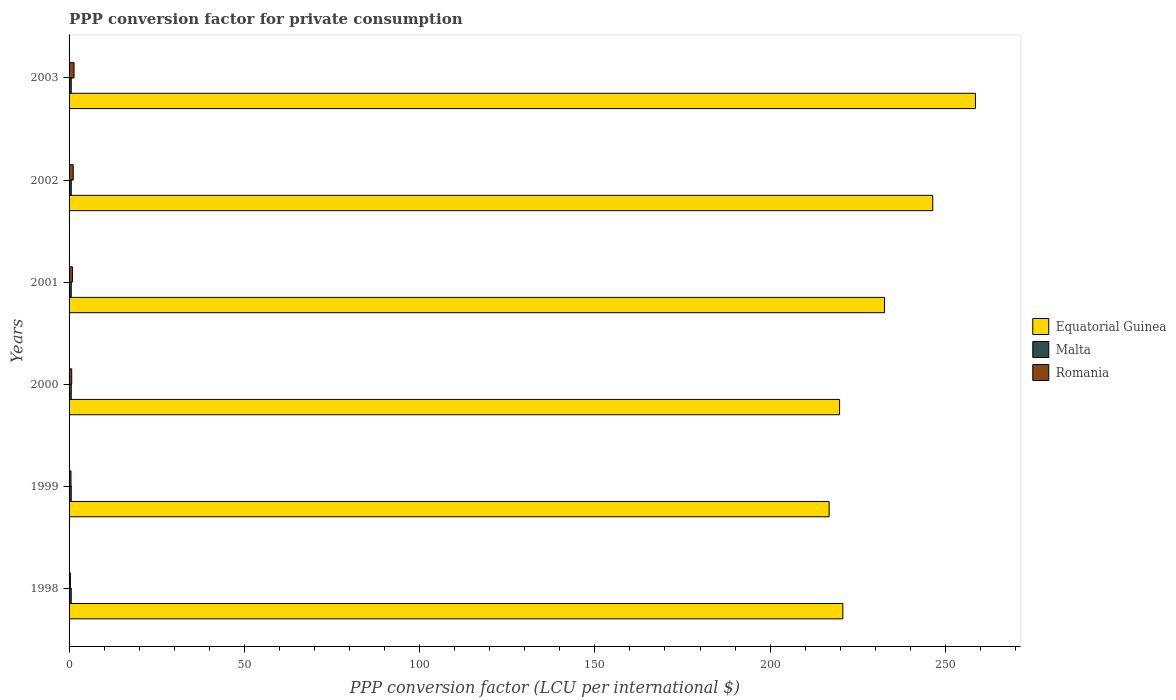How many different coloured bars are there?
Your response must be concise. 3. How many groups of bars are there?
Your answer should be very brief. 6. Are the number of bars per tick equal to the number of legend labels?
Provide a short and direct response. Yes. In how many cases, is the number of bars for a given year not equal to the number of legend labels?
Provide a succinct answer. 0. What is the PPP conversion factor for private consumption in Equatorial Guinea in 2000?
Give a very brief answer. 219.83. Across all years, what is the maximum PPP conversion factor for private consumption in Equatorial Guinea?
Provide a succinct answer. 258.58. Across all years, what is the minimum PPP conversion factor for private consumption in Malta?
Your response must be concise. 0.62. In which year was the PPP conversion factor for private consumption in Romania maximum?
Your response must be concise. 2003. What is the total PPP conversion factor for private consumption in Romania in the graph?
Provide a succinct answer. 5.26. What is the difference between the PPP conversion factor for private consumption in Romania in 2000 and that in 2001?
Offer a terse response. -0.2. What is the difference between the PPP conversion factor for private consumption in Equatorial Guinea in 1999 and the PPP conversion factor for private consumption in Malta in 2003?
Your answer should be compact. 216.21. What is the average PPP conversion factor for private consumption in Equatorial Guinea per year?
Offer a very short reply. 232.51. In the year 2003, what is the difference between the PPP conversion factor for private consumption in Equatorial Guinea and PPP conversion factor for private consumption in Malta?
Provide a short and direct response. 257.96. In how many years, is the PPP conversion factor for private consumption in Romania greater than 40 LCU?
Keep it short and to the point. 0. What is the ratio of the PPP conversion factor for private consumption in Malta in 1999 to that in 2001?
Make the answer very short. 1. Is the PPP conversion factor for private consumption in Romania in 2000 less than that in 2001?
Give a very brief answer. Yes. What is the difference between the highest and the second highest PPP conversion factor for private consumption in Romania?
Your answer should be very brief. 0.23. What is the difference between the highest and the lowest PPP conversion factor for private consumption in Malta?
Keep it short and to the point. 0.01. What does the 3rd bar from the top in 2001 represents?
Provide a succinct answer. Equatorial Guinea. What does the 2nd bar from the bottom in 2001 represents?
Offer a very short reply. Malta. Is it the case that in every year, the sum of the PPP conversion factor for private consumption in Malta and PPP conversion factor for private consumption in Romania is greater than the PPP conversion factor for private consumption in Equatorial Guinea?
Make the answer very short. No. Are all the bars in the graph horizontal?
Make the answer very short. Yes. What is the difference between two consecutive major ticks on the X-axis?
Ensure brevity in your answer.  50. Does the graph contain any zero values?
Provide a short and direct response. No. Does the graph contain grids?
Your response must be concise. No. How are the legend labels stacked?
Your answer should be very brief. Vertical. What is the title of the graph?
Provide a succinct answer. PPP conversion factor for private consumption. What is the label or title of the X-axis?
Your answer should be very brief. PPP conversion factor (LCU per international $). What is the label or title of the Y-axis?
Give a very brief answer. Years. What is the PPP conversion factor (LCU per international $) in Equatorial Guinea in 1998?
Your answer should be very brief. 220.76. What is the PPP conversion factor (LCU per international $) in Malta in 1998?
Your response must be concise. 0.62. What is the PPP conversion factor (LCU per international $) in Romania in 1998?
Provide a short and direct response. 0.38. What is the PPP conversion factor (LCU per international $) in Equatorial Guinea in 1999?
Offer a very short reply. 216.84. What is the PPP conversion factor (LCU per international $) in Malta in 1999?
Your answer should be compact. 0.62. What is the PPP conversion factor (LCU per international $) in Romania in 1999?
Offer a terse response. 0.55. What is the PPP conversion factor (LCU per international $) of Equatorial Guinea in 2000?
Make the answer very short. 219.83. What is the PPP conversion factor (LCU per international $) in Malta in 2000?
Provide a succinct answer. 0.62. What is the PPP conversion factor (LCU per international $) in Romania in 2000?
Your response must be concise. 0.76. What is the PPP conversion factor (LCU per international $) in Equatorial Guinea in 2001?
Offer a very short reply. 232.65. What is the PPP conversion factor (LCU per international $) in Malta in 2001?
Offer a very short reply. 0.62. What is the PPP conversion factor (LCU per international $) in Romania in 2001?
Provide a succinct answer. 0.96. What is the PPP conversion factor (LCU per international $) of Equatorial Guinea in 2002?
Your answer should be compact. 246.41. What is the PPP conversion factor (LCU per international $) of Malta in 2002?
Make the answer very short. 0.63. What is the PPP conversion factor (LCU per international $) in Romania in 2002?
Your answer should be very brief. 1.19. What is the PPP conversion factor (LCU per international $) in Equatorial Guinea in 2003?
Make the answer very short. 258.58. What is the PPP conversion factor (LCU per international $) in Malta in 2003?
Offer a terse response. 0.62. What is the PPP conversion factor (LCU per international $) in Romania in 2003?
Offer a very short reply. 1.42. Across all years, what is the maximum PPP conversion factor (LCU per international $) of Equatorial Guinea?
Offer a very short reply. 258.58. Across all years, what is the maximum PPP conversion factor (LCU per international $) in Malta?
Keep it short and to the point. 0.63. Across all years, what is the maximum PPP conversion factor (LCU per international $) in Romania?
Give a very brief answer. 1.42. Across all years, what is the minimum PPP conversion factor (LCU per international $) in Equatorial Guinea?
Provide a succinct answer. 216.84. Across all years, what is the minimum PPP conversion factor (LCU per international $) in Malta?
Offer a terse response. 0.62. Across all years, what is the minimum PPP conversion factor (LCU per international $) of Romania?
Ensure brevity in your answer.  0.38. What is the total PPP conversion factor (LCU per international $) in Equatorial Guinea in the graph?
Offer a very short reply. 1395.06. What is the total PPP conversion factor (LCU per international $) of Malta in the graph?
Your answer should be compact. 3.73. What is the total PPP conversion factor (LCU per international $) in Romania in the graph?
Your response must be concise. 5.26. What is the difference between the PPP conversion factor (LCU per international $) of Equatorial Guinea in 1998 and that in 1999?
Offer a very short reply. 3.92. What is the difference between the PPP conversion factor (LCU per international $) of Malta in 1998 and that in 1999?
Your answer should be very brief. 0. What is the difference between the PPP conversion factor (LCU per international $) of Romania in 1998 and that in 1999?
Ensure brevity in your answer.  -0.17. What is the difference between the PPP conversion factor (LCU per international $) of Equatorial Guinea in 1998 and that in 2000?
Your answer should be compact. 0.93. What is the difference between the PPP conversion factor (LCU per international $) in Malta in 1998 and that in 2000?
Give a very brief answer. 0.01. What is the difference between the PPP conversion factor (LCU per international $) of Romania in 1998 and that in 2000?
Give a very brief answer. -0.38. What is the difference between the PPP conversion factor (LCU per international $) of Equatorial Guinea in 1998 and that in 2001?
Your response must be concise. -11.89. What is the difference between the PPP conversion factor (LCU per international $) in Malta in 1998 and that in 2001?
Your answer should be compact. 0. What is the difference between the PPP conversion factor (LCU per international $) in Romania in 1998 and that in 2001?
Provide a succinct answer. -0.58. What is the difference between the PPP conversion factor (LCU per international $) in Equatorial Guinea in 1998 and that in 2002?
Offer a very short reply. -25.65. What is the difference between the PPP conversion factor (LCU per international $) of Malta in 1998 and that in 2002?
Provide a short and direct response. -0. What is the difference between the PPP conversion factor (LCU per international $) in Romania in 1998 and that in 2002?
Your answer should be very brief. -0.81. What is the difference between the PPP conversion factor (LCU per international $) in Equatorial Guinea in 1998 and that in 2003?
Provide a short and direct response. -37.82. What is the difference between the PPP conversion factor (LCU per international $) in Malta in 1998 and that in 2003?
Make the answer very short. 0. What is the difference between the PPP conversion factor (LCU per international $) of Romania in 1998 and that in 2003?
Provide a succinct answer. -1.04. What is the difference between the PPP conversion factor (LCU per international $) of Equatorial Guinea in 1999 and that in 2000?
Your answer should be compact. -2.99. What is the difference between the PPP conversion factor (LCU per international $) of Malta in 1999 and that in 2000?
Give a very brief answer. 0. What is the difference between the PPP conversion factor (LCU per international $) of Romania in 1999 and that in 2000?
Your response must be concise. -0.21. What is the difference between the PPP conversion factor (LCU per international $) of Equatorial Guinea in 1999 and that in 2001?
Your response must be concise. -15.82. What is the difference between the PPP conversion factor (LCU per international $) of Romania in 1999 and that in 2001?
Keep it short and to the point. -0.41. What is the difference between the PPP conversion factor (LCU per international $) in Equatorial Guinea in 1999 and that in 2002?
Offer a terse response. -29.57. What is the difference between the PPP conversion factor (LCU per international $) in Malta in 1999 and that in 2002?
Give a very brief answer. -0.01. What is the difference between the PPP conversion factor (LCU per international $) in Romania in 1999 and that in 2002?
Provide a short and direct response. -0.64. What is the difference between the PPP conversion factor (LCU per international $) of Equatorial Guinea in 1999 and that in 2003?
Keep it short and to the point. -41.75. What is the difference between the PPP conversion factor (LCU per international $) of Malta in 1999 and that in 2003?
Make the answer very short. -0. What is the difference between the PPP conversion factor (LCU per international $) of Romania in 1999 and that in 2003?
Keep it short and to the point. -0.87. What is the difference between the PPP conversion factor (LCU per international $) in Equatorial Guinea in 2000 and that in 2001?
Make the answer very short. -12.83. What is the difference between the PPP conversion factor (LCU per international $) in Malta in 2000 and that in 2001?
Provide a succinct answer. -0. What is the difference between the PPP conversion factor (LCU per international $) in Romania in 2000 and that in 2001?
Ensure brevity in your answer.  -0.2. What is the difference between the PPP conversion factor (LCU per international $) in Equatorial Guinea in 2000 and that in 2002?
Keep it short and to the point. -26.58. What is the difference between the PPP conversion factor (LCU per international $) in Malta in 2000 and that in 2002?
Your answer should be compact. -0.01. What is the difference between the PPP conversion factor (LCU per international $) in Romania in 2000 and that in 2002?
Your response must be concise. -0.43. What is the difference between the PPP conversion factor (LCU per international $) in Equatorial Guinea in 2000 and that in 2003?
Provide a short and direct response. -38.76. What is the difference between the PPP conversion factor (LCU per international $) of Malta in 2000 and that in 2003?
Your response must be concise. -0.01. What is the difference between the PPP conversion factor (LCU per international $) in Romania in 2000 and that in 2003?
Provide a short and direct response. -0.66. What is the difference between the PPP conversion factor (LCU per international $) of Equatorial Guinea in 2001 and that in 2002?
Provide a succinct answer. -13.76. What is the difference between the PPP conversion factor (LCU per international $) in Malta in 2001 and that in 2002?
Your answer should be compact. -0.01. What is the difference between the PPP conversion factor (LCU per international $) in Romania in 2001 and that in 2002?
Offer a terse response. -0.23. What is the difference between the PPP conversion factor (LCU per international $) in Equatorial Guinea in 2001 and that in 2003?
Your response must be concise. -25.93. What is the difference between the PPP conversion factor (LCU per international $) in Malta in 2001 and that in 2003?
Offer a very short reply. -0. What is the difference between the PPP conversion factor (LCU per international $) in Romania in 2001 and that in 2003?
Offer a terse response. -0.46. What is the difference between the PPP conversion factor (LCU per international $) of Equatorial Guinea in 2002 and that in 2003?
Provide a succinct answer. -12.18. What is the difference between the PPP conversion factor (LCU per international $) in Malta in 2002 and that in 2003?
Your answer should be very brief. 0.01. What is the difference between the PPP conversion factor (LCU per international $) of Romania in 2002 and that in 2003?
Ensure brevity in your answer.  -0.23. What is the difference between the PPP conversion factor (LCU per international $) of Equatorial Guinea in 1998 and the PPP conversion factor (LCU per international $) of Malta in 1999?
Your response must be concise. 220.14. What is the difference between the PPP conversion factor (LCU per international $) of Equatorial Guinea in 1998 and the PPP conversion factor (LCU per international $) of Romania in 1999?
Your response must be concise. 220.21. What is the difference between the PPP conversion factor (LCU per international $) in Malta in 1998 and the PPP conversion factor (LCU per international $) in Romania in 1999?
Offer a terse response. 0.07. What is the difference between the PPP conversion factor (LCU per international $) of Equatorial Guinea in 1998 and the PPP conversion factor (LCU per international $) of Malta in 2000?
Your response must be concise. 220.14. What is the difference between the PPP conversion factor (LCU per international $) in Equatorial Guinea in 1998 and the PPP conversion factor (LCU per international $) in Romania in 2000?
Ensure brevity in your answer.  220. What is the difference between the PPP conversion factor (LCU per international $) of Malta in 1998 and the PPP conversion factor (LCU per international $) of Romania in 2000?
Your answer should be compact. -0.13. What is the difference between the PPP conversion factor (LCU per international $) in Equatorial Guinea in 1998 and the PPP conversion factor (LCU per international $) in Malta in 2001?
Keep it short and to the point. 220.14. What is the difference between the PPP conversion factor (LCU per international $) of Equatorial Guinea in 1998 and the PPP conversion factor (LCU per international $) of Romania in 2001?
Your response must be concise. 219.8. What is the difference between the PPP conversion factor (LCU per international $) of Malta in 1998 and the PPP conversion factor (LCU per international $) of Romania in 2001?
Give a very brief answer. -0.34. What is the difference between the PPP conversion factor (LCU per international $) in Equatorial Guinea in 1998 and the PPP conversion factor (LCU per international $) in Malta in 2002?
Make the answer very short. 220.13. What is the difference between the PPP conversion factor (LCU per international $) in Equatorial Guinea in 1998 and the PPP conversion factor (LCU per international $) in Romania in 2002?
Your response must be concise. 219.57. What is the difference between the PPP conversion factor (LCU per international $) of Malta in 1998 and the PPP conversion factor (LCU per international $) of Romania in 2002?
Your response must be concise. -0.56. What is the difference between the PPP conversion factor (LCU per international $) of Equatorial Guinea in 1998 and the PPP conversion factor (LCU per international $) of Malta in 2003?
Provide a succinct answer. 220.14. What is the difference between the PPP conversion factor (LCU per international $) of Equatorial Guinea in 1998 and the PPP conversion factor (LCU per international $) of Romania in 2003?
Give a very brief answer. 219.34. What is the difference between the PPP conversion factor (LCU per international $) in Malta in 1998 and the PPP conversion factor (LCU per international $) in Romania in 2003?
Your answer should be very brief. -0.8. What is the difference between the PPP conversion factor (LCU per international $) in Equatorial Guinea in 1999 and the PPP conversion factor (LCU per international $) in Malta in 2000?
Ensure brevity in your answer.  216.22. What is the difference between the PPP conversion factor (LCU per international $) of Equatorial Guinea in 1999 and the PPP conversion factor (LCU per international $) of Romania in 2000?
Your response must be concise. 216.08. What is the difference between the PPP conversion factor (LCU per international $) in Malta in 1999 and the PPP conversion factor (LCU per international $) in Romania in 2000?
Your answer should be very brief. -0.14. What is the difference between the PPP conversion factor (LCU per international $) in Equatorial Guinea in 1999 and the PPP conversion factor (LCU per international $) in Malta in 2001?
Make the answer very short. 216.21. What is the difference between the PPP conversion factor (LCU per international $) of Equatorial Guinea in 1999 and the PPP conversion factor (LCU per international $) of Romania in 2001?
Ensure brevity in your answer.  215.87. What is the difference between the PPP conversion factor (LCU per international $) of Malta in 1999 and the PPP conversion factor (LCU per international $) of Romania in 2001?
Your answer should be very brief. -0.34. What is the difference between the PPP conversion factor (LCU per international $) in Equatorial Guinea in 1999 and the PPP conversion factor (LCU per international $) in Malta in 2002?
Your answer should be very brief. 216.21. What is the difference between the PPP conversion factor (LCU per international $) in Equatorial Guinea in 1999 and the PPP conversion factor (LCU per international $) in Romania in 2002?
Your answer should be very brief. 215.65. What is the difference between the PPP conversion factor (LCU per international $) in Malta in 1999 and the PPP conversion factor (LCU per international $) in Romania in 2002?
Offer a terse response. -0.56. What is the difference between the PPP conversion factor (LCU per international $) in Equatorial Guinea in 1999 and the PPP conversion factor (LCU per international $) in Malta in 2003?
Keep it short and to the point. 216.21. What is the difference between the PPP conversion factor (LCU per international $) in Equatorial Guinea in 1999 and the PPP conversion factor (LCU per international $) in Romania in 2003?
Your answer should be compact. 215.42. What is the difference between the PPP conversion factor (LCU per international $) of Malta in 1999 and the PPP conversion factor (LCU per international $) of Romania in 2003?
Offer a terse response. -0.8. What is the difference between the PPP conversion factor (LCU per international $) in Equatorial Guinea in 2000 and the PPP conversion factor (LCU per international $) in Malta in 2001?
Offer a terse response. 219.2. What is the difference between the PPP conversion factor (LCU per international $) of Equatorial Guinea in 2000 and the PPP conversion factor (LCU per international $) of Romania in 2001?
Your answer should be very brief. 218.86. What is the difference between the PPP conversion factor (LCU per international $) of Malta in 2000 and the PPP conversion factor (LCU per international $) of Romania in 2001?
Offer a very short reply. -0.34. What is the difference between the PPP conversion factor (LCU per international $) of Equatorial Guinea in 2000 and the PPP conversion factor (LCU per international $) of Malta in 2002?
Your answer should be very brief. 219.2. What is the difference between the PPP conversion factor (LCU per international $) in Equatorial Guinea in 2000 and the PPP conversion factor (LCU per international $) in Romania in 2002?
Provide a succinct answer. 218.64. What is the difference between the PPP conversion factor (LCU per international $) of Malta in 2000 and the PPP conversion factor (LCU per international $) of Romania in 2002?
Give a very brief answer. -0.57. What is the difference between the PPP conversion factor (LCU per international $) in Equatorial Guinea in 2000 and the PPP conversion factor (LCU per international $) in Malta in 2003?
Provide a short and direct response. 219.2. What is the difference between the PPP conversion factor (LCU per international $) of Equatorial Guinea in 2000 and the PPP conversion factor (LCU per international $) of Romania in 2003?
Your response must be concise. 218.41. What is the difference between the PPP conversion factor (LCU per international $) of Malta in 2000 and the PPP conversion factor (LCU per international $) of Romania in 2003?
Your answer should be very brief. -0.8. What is the difference between the PPP conversion factor (LCU per international $) of Equatorial Guinea in 2001 and the PPP conversion factor (LCU per international $) of Malta in 2002?
Offer a terse response. 232.02. What is the difference between the PPP conversion factor (LCU per international $) in Equatorial Guinea in 2001 and the PPP conversion factor (LCU per international $) in Romania in 2002?
Keep it short and to the point. 231.46. What is the difference between the PPP conversion factor (LCU per international $) in Malta in 2001 and the PPP conversion factor (LCU per international $) in Romania in 2002?
Ensure brevity in your answer.  -0.57. What is the difference between the PPP conversion factor (LCU per international $) in Equatorial Guinea in 2001 and the PPP conversion factor (LCU per international $) in Malta in 2003?
Make the answer very short. 232.03. What is the difference between the PPP conversion factor (LCU per international $) of Equatorial Guinea in 2001 and the PPP conversion factor (LCU per international $) of Romania in 2003?
Provide a short and direct response. 231.23. What is the difference between the PPP conversion factor (LCU per international $) of Malta in 2001 and the PPP conversion factor (LCU per international $) of Romania in 2003?
Provide a short and direct response. -0.8. What is the difference between the PPP conversion factor (LCU per international $) of Equatorial Guinea in 2002 and the PPP conversion factor (LCU per international $) of Malta in 2003?
Give a very brief answer. 245.78. What is the difference between the PPP conversion factor (LCU per international $) of Equatorial Guinea in 2002 and the PPP conversion factor (LCU per international $) of Romania in 2003?
Your answer should be very brief. 244.99. What is the difference between the PPP conversion factor (LCU per international $) of Malta in 2002 and the PPP conversion factor (LCU per international $) of Romania in 2003?
Keep it short and to the point. -0.79. What is the average PPP conversion factor (LCU per international $) of Equatorial Guinea per year?
Give a very brief answer. 232.51. What is the average PPP conversion factor (LCU per international $) in Malta per year?
Your answer should be compact. 0.62. What is the average PPP conversion factor (LCU per international $) of Romania per year?
Your answer should be very brief. 0.88. In the year 1998, what is the difference between the PPP conversion factor (LCU per international $) of Equatorial Guinea and PPP conversion factor (LCU per international $) of Malta?
Give a very brief answer. 220.14. In the year 1998, what is the difference between the PPP conversion factor (LCU per international $) in Equatorial Guinea and PPP conversion factor (LCU per international $) in Romania?
Your answer should be compact. 220.38. In the year 1998, what is the difference between the PPP conversion factor (LCU per international $) in Malta and PPP conversion factor (LCU per international $) in Romania?
Give a very brief answer. 0.24. In the year 1999, what is the difference between the PPP conversion factor (LCU per international $) in Equatorial Guinea and PPP conversion factor (LCU per international $) in Malta?
Your answer should be very brief. 216.21. In the year 1999, what is the difference between the PPP conversion factor (LCU per international $) of Equatorial Guinea and PPP conversion factor (LCU per international $) of Romania?
Give a very brief answer. 216.28. In the year 1999, what is the difference between the PPP conversion factor (LCU per international $) of Malta and PPP conversion factor (LCU per international $) of Romania?
Provide a succinct answer. 0.07. In the year 2000, what is the difference between the PPP conversion factor (LCU per international $) of Equatorial Guinea and PPP conversion factor (LCU per international $) of Malta?
Offer a very short reply. 219.21. In the year 2000, what is the difference between the PPP conversion factor (LCU per international $) in Equatorial Guinea and PPP conversion factor (LCU per international $) in Romania?
Your answer should be very brief. 219.07. In the year 2000, what is the difference between the PPP conversion factor (LCU per international $) in Malta and PPP conversion factor (LCU per international $) in Romania?
Make the answer very short. -0.14. In the year 2001, what is the difference between the PPP conversion factor (LCU per international $) of Equatorial Guinea and PPP conversion factor (LCU per international $) of Malta?
Give a very brief answer. 232.03. In the year 2001, what is the difference between the PPP conversion factor (LCU per international $) of Equatorial Guinea and PPP conversion factor (LCU per international $) of Romania?
Make the answer very short. 231.69. In the year 2001, what is the difference between the PPP conversion factor (LCU per international $) of Malta and PPP conversion factor (LCU per international $) of Romania?
Offer a terse response. -0.34. In the year 2002, what is the difference between the PPP conversion factor (LCU per international $) in Equatorial Guinea and PPP conversion factor (LCU per international $) in Malta?
Provide a short and direct response. 245.78. In the year 2002, what is the difference between the PPP conversion factor (LCU per international $) of Equatorial Guinea and PPP conversion factor (LCU per international $) of Romania?
Provide a short and direct response. 245.22. In the year 2002, what is the difference between the PPP conversion factor (LCU per international $) in Malta and PPP conversion factor (LCU per international $) in Romania?
Offer a terse response. -0.56. In the year 2003, what is the difference between the PPP conversion factor (LCU per international $) of Equatorial Guinea and PPP conversion factor (LCU per international $) of Malta?
Your answer should be very brief. 257.96. In the year 2003, what is the difference between the PPP conversion factor (LCU per international $) of Equatorial Guinea and PPP conversion factor (LCU per international $) of Romania?
Ensure brevity in your answer.  257.16. In the year 2003, what is the difference between the PPP conversion factor (LCU per international $) in Malta and PPP conversion factor (LCU per international $) in Romania?
Your answer should be very brief. -0.8. What is the ratio of the PPP conversion factor (LCU per international $) of Equatorial Guinea in 1998 to that in 1999?
Provide a succinct answer. 1.02. What is the ratio of the PPP conversion factor (LCU per international $) of Malta in 1998 to that in 1999?
Your answer should be very brief. 1. What is the ratio of the PPP conversion factor (LCU per international $) in Romania in 1998 to that in 1999?
Make the answer very short. 0.69. What is the ratio of the PPP conversion factor (LCU per international $) in Malta in 1998 to that in 2000?
Your answer should be very brief. 1.01. What is the ratio of the PPP conversion factor (LCU per international $) in Romania in 1998 to that in 2000?
Provide a succinct answer. 0.5. What is the ratio of the PPP conversion factor (LCU per international $) in Equatorial Guinea in 1998 to that in 2001?
Offer a very short reply. 0.95. What is the ratio of the PPP conversion factor (LCU per international $) in Romania in 1998 to that in 2001?
Your response must be concise. 0.4. What is the ratio of the PPP conversion factor (LCU per international $) in Equatorial Guinea in 1998 to that in 2002?
Give a very brief answer. 0.9. What is the ratio of the PPP conversion factor (LCU per international $) of Malta in 1998 to that in 2002?
Give a very brief answer. 0.99. What is the ratio of the PPP conversion factor (LCU per international $) in Romania in 1998 to that in 2002?
Give a very brief answer. 0.32. What is the ratio of the PPP conversion factor (LCU per international $) in Equatorial Guinea in 1998 to that in 2003?
Offer a very short reply. 0.85. What is the ratio of the PPP conversion factor (LCU per international $) in Malta in 1998 to that in 2003?
Offer a very short reply. 1. What is the ratio of the PPP conversion factor (LCU per international $) in Romania in 1998 to that in 2003?
Offer a very short reply. 0.27. What is the ratio of the PPP conversion factor (LCU per international $) in Equatorial Guinea in 1999 to that in 2000?
Provide a succinct answer. 0.99. What is the ratio of the PPP conversion factor (LCU per international $) of Romania in 1999 to that in 2000?
Offer a terse response. 0.73. What is the ratio of the PPP conversion factor (LCU per international $) in Equatorial Guinea in 1999 to that in 2001?
Keep it short and to the point. 0.93. What is the ratio of the PPP conversion factor (LCU per international $) in Malta in 1999 to that in 2001?
Keep it short and to the point. 1. What is the ratio of the PPP conversion factor (LCU per international $) of Romania in 1999 to that in 2001?
Provide a short and direct response. 0.57. What is the ratio of the PPP conversion factor (LCU per international $) in Equatorial Guinea in 1999 to that in 2002?
Your answer should be very brief. 0.88. What is the ratio of the PPP conversion factor (LCU per international $) in Malta in 1999 to that in 2002?
Keep it short and to the point. 0.99. What is the ratio of the PPP conversion factor (LCU per international $) of Romania in 1999 to that in 2002?
Offer a very short reply. 0.46. What is the ratio of the PPP conversion factor (LCU per international $) in Equatorial Guinea in 1999 to that in 2003?
Provide a succinct answer. 0.84. What is the ratio of the PPP conversion factor (LCU per international $) of Romania in 1999 to that in 2003?
Provide a succinct answer. 0.39. What is the ratio of the PPP conversion factor (LCU per international $) in Equatorial Guinea in 2000 to that in 2001?
Offer a very short reply. 0.94. What is the ratio of the PPP conversion factor (LCU per international $) in Malta in 2000 to that in 2001?
Your answer should be compact. 0.99. What is the ratio of the PPP conversion factor (LCU per international $) in Romania in 2000 to that in 2001?
Your answer should be very brief. 0.79. What is the ratio of the PPP conversion factor (LCU per international $) in Equatorial Guinea in 2000 to that in 2002?
Your response must be concise. 0.89. What is the ratio of the PPP conversion factor (LCU per international $) in Malta in 2000 to that in 2002?
Your answer should be very brief. 0.98. What is the ratio of the PPP conversion factor (LCU per international $) of Romania in 2000 to that in 2002?
Keep it short and to the point. 0.64. What is the ratio of the PPP conversion factor (LCU per international $) in Equatorial Guinea in 2000 to that in 2003?
Offer a terse response. 0.85. What is the ratio of the PPP conversion factor (LCU per international $) in Malta in 2000 to that in 2003?
Make the answer very short. 0.99. What is the ratio of the PPP conversion factor (LCU per international $) in Romania in 2000 to that in 2003?
Your answer should be very brief. 0.53. What is the ratio of the PPP conversion factor (LCU per international $) in Equatorial Guinea in 2001 to that in 2002?
Offer a very short reply. 0.94. What is the ratio of the PPP conversion factor (LCU per international $) of Romania in 2001 to that in 2002?
Offer a very short reply. 0.81. What is the ratio of the PPP conversion factor (LCU per international $) of Equatorial Guinea in 2001 to that in 2003?
Keep it short and to the point. 0.9. What is the ratio of the PPP conversion factor (LCU per international $) of Malta in 2001 to that in 2003?
Provide a short and direct response. 1. What is the ratio of the PPP conversion factor (LCU per international $) of Romania in 2001 to that in 2003?
Offer a very short reply. 0.68. What is the ratio of the PPP conversion factor (LCU per international $) of Equatorial Guinea in 2002 to that in 2003?
Provide a short and direct response. 0.95. What is the ratio of the PPP conversion factor (LCU per international $) of Malta in 2002 to that in 2003?
Provide a short and direct response. 1.01. What is the ratio of the PPP conversion factor (LCU per international $) in Romania in 2002 to that in 2003?
Your answer should be compact. 0.84. What is the difference between the highest and the second highest PPP conversion factor (LCU per international $) of Equatorial Guinea?
Offer a very short reply. 12.18. What is the difference between the highest and the second highest PPP conversion factor (LCU per international $) in Malta?
Your answer should be compact. 0. What is the difference between the highest and the second highest PPP conversion factor (LCU per international $) in Romania?
Your answer should be very brief. 0.23. What is the difference between the highest and the lowest PPP conversion factor (LCU per international $) in Equatorial Guinea?
Keep it short and to the point. 41.75. What is the difference between the highest and the lowest PPP conversion factor (LCU per international $) in Malta?
Ensure brevity in your answer.  0.01. What is the difference between the highest and the lowest PPP conversion factor (LCU per international $) in Romania?
Ensure brevity in your answer.  1.04. 